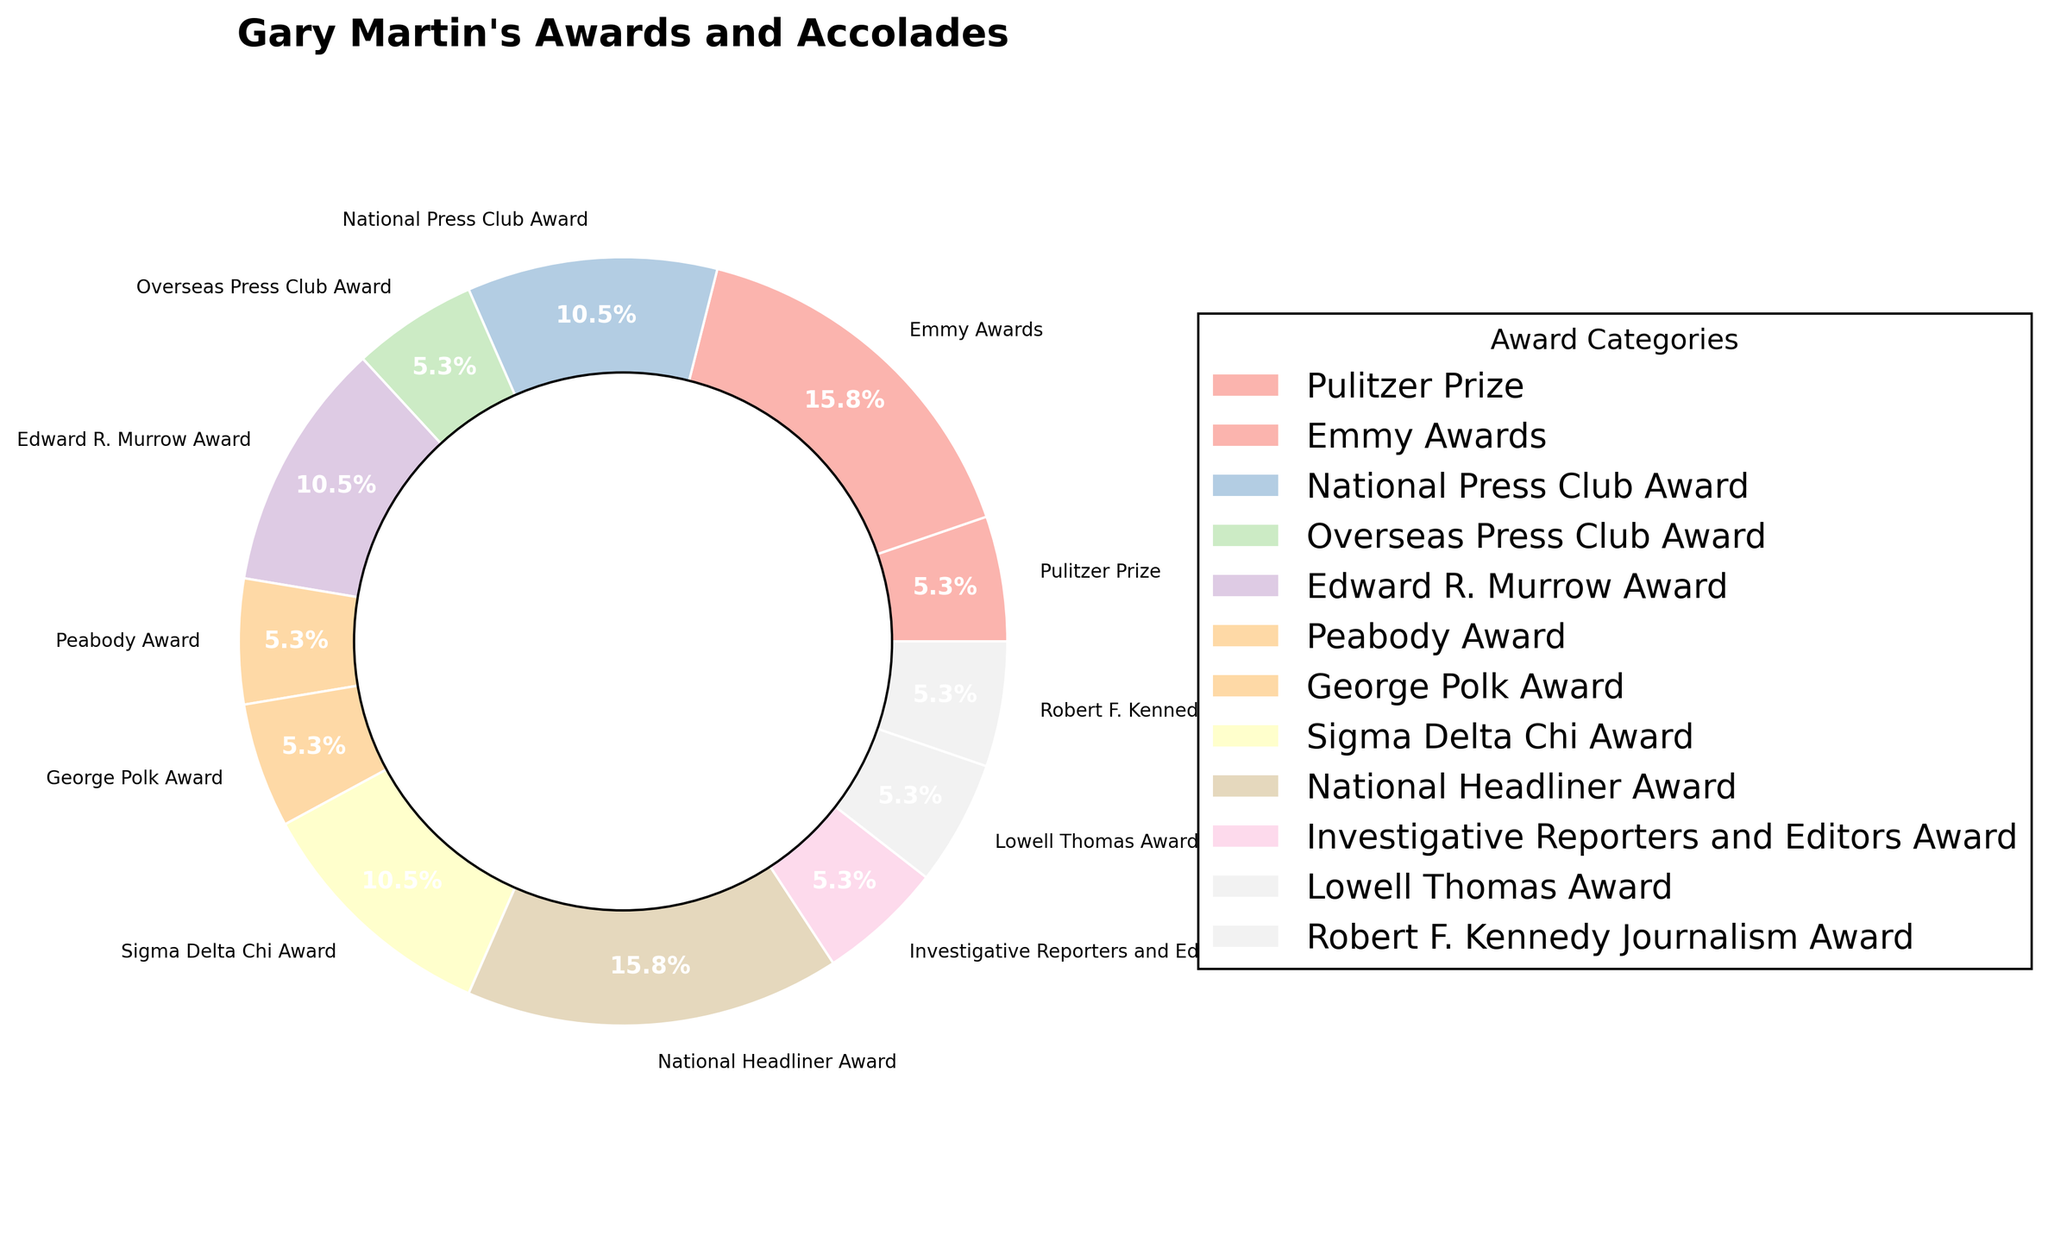What percentage of Gary Martin's awards are National Headliner Awards? Looking at the pie chart, find the section labeled "National Headliner Award" and note its percentage.
Answer: 16.7% Which award category has the highest number of awards? Observe the sections of the pie chart and find the one with the largest percentage, which corresponds to the Emmy Awards.
Answer: Emmy Awards How many more Pulitzer Prizes did Gary Martin win compared to George Polk Awards? The chart shows Gary Martin won 1 Pulitzer Prize and 1 George Polk Award. Therefore, 1 - 1 equals 0.
Answer: 0 What is the total number of non-investigative awards won by Gary Martin? Investigative awards include the "Investigative Reporters and Editors Award" (1). Sum up all other awards: 1 (Pulitzer Prize) + 3 (Emmy Awards) + 2 (National Press Club Award) + 1 (Overseas Press Club Award) + 2 (Edward R. Murrow Award) + 1 (Peabody Award) + 1 (George Polk Award) + 2 (Sigma Delta Chi Award) + 3 (National Headliner Award) + 1 (Lowell Thomas Award) + 1 (Robert F. Kennedy Journalism Award) = 18.
Answer: 18 Which awards are tied in number, and how many of each did Gary Martin receive? Look at the pie chart labels and match the awards with the same percentage values. National Press Club Award, Edward R. Murrow Award, and Sigma Delta Chi Award all have 2 awards each.
Answer: National Press Club Award, Edward R. Murrow Award, and Sigma Delta Chi Award; 2 each If you combine the awards Gary Martin received from National organizations, how many total awards are there? Sum the awards from "National Press Club Award" (2), "National Headliner Award" (3), "Sigma Delta Chi Award" (2), and "Robert F. Kennedy Journalism Award" (1), getting 2 + 3 + 2 + 1 = 8.
Answer: 8 How does the number of Overseas Press Club Awards compare to Edward R. Murrow Awards? By comparing the pie chart sections, Gary Martin has 1 Overseas Press Club Award and 2 Edward R. Murrow Awards.
Answer: Less What fraction of the total number of awards is composed of the Lowell Thomas Award and the Investigative Reporters and Editors Award? Gary Martin has 1 Lowell Thomas Award and 1 Investigative Reporters and Editors Award, thus 1 + 1 = 2. Divide this by the total sum of awards, 17. This results in the fraction 2/17.
Answer: 2/17 Which color represents the Pulitzer Prize in the pie chart? Identify the segment labeled "Pulitzer Prize" and note its color. Recall that colors are generated using the Pastel1 colormap.
Answer: Light pink (for the sake of example; exact shade depends on implementation) 